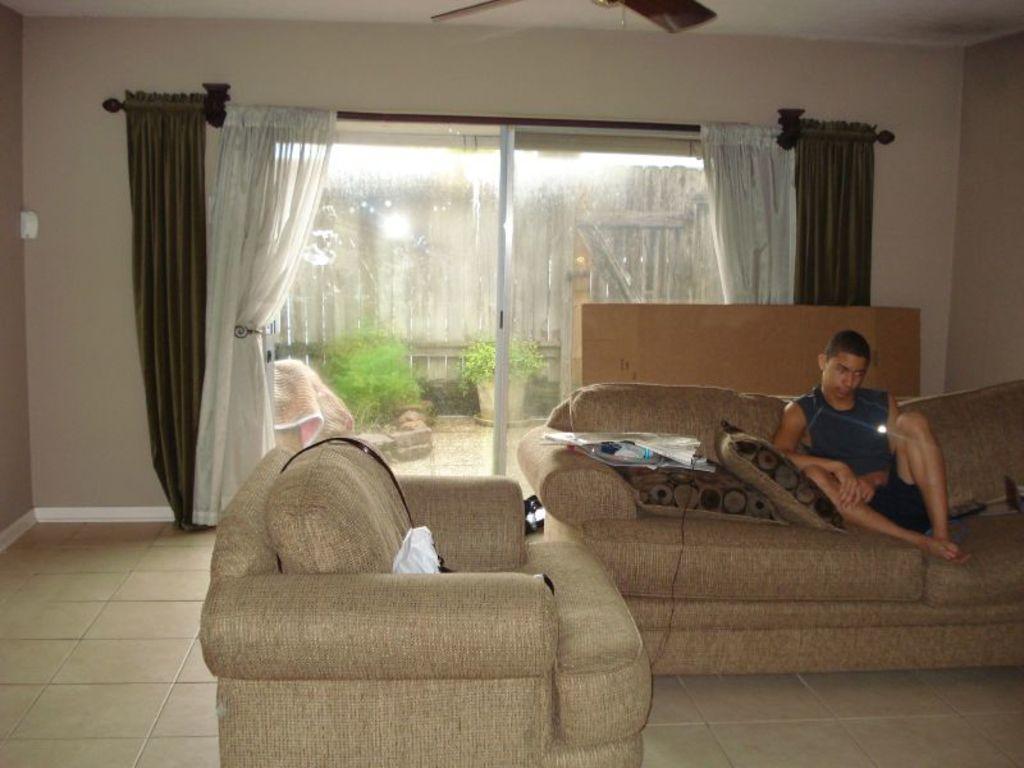Can you describe this image briefly? This is a picture of a living room where there are couch, pillows, covers , a man sitting in a couch , card board box,curtains, window, plants, blanket ,fan, wall, wooden fence. 